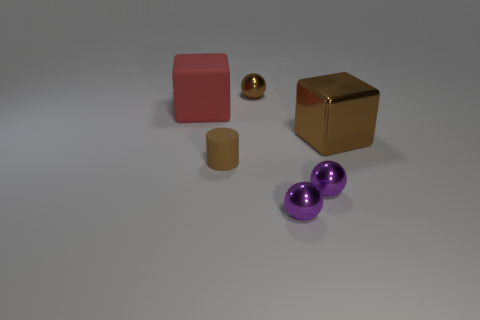Can you describe the colors and materials of the objects in this image? Certainly! The image features a collection of objects with various colors and materials. We have a red cube and a golden cube that exhibits a reflective metallic surface. There's also a brown cylinder with a matte finish, similar to rubber, and a shiny brown sphere with a polished look. Lastly, there are two purple shiny spheres, which appear to be reflective as well. 